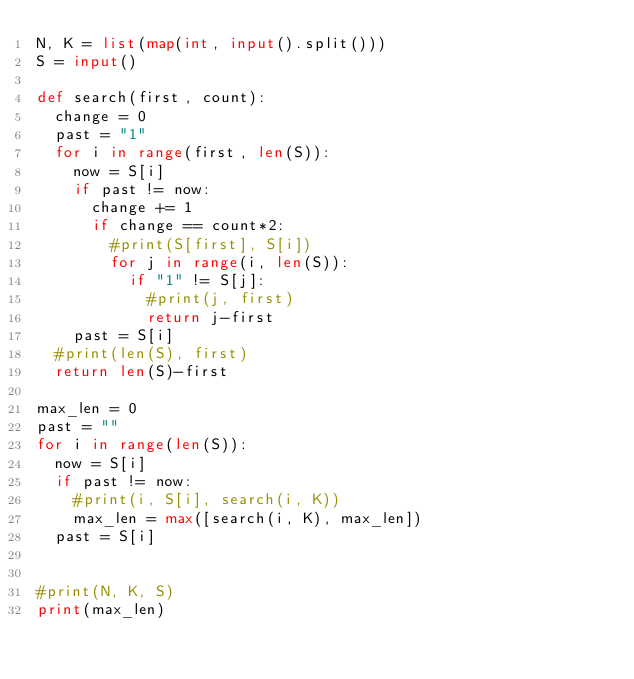<code> <loc_0><loc_0><loc_500><loc_500><_Python_>N, K = list(map(int, input().split()))
S = input()

def search(first, count):
  change = 0
  past = "1"
  for i in range(first, len(S)):
    now = S[i]
    if past != now:
      change += 1
      if change == count*2:
        #print(S[first], S[i])
        for j in range(i, len(S)):
          if "1" != S[j]:
            #print(j, first)
            return j-first
    past = S[i]
  #print(len(S), first)
  return len(S)-first

max_len = 0
past = ""
for i in range(len(S)):
  now = S[i]
  if past != now:
    #print(i, S[i], search(i, K))
    max_len = max([search(i, K), max_len])
  past = S[i] 
  

#print(N, K, S)
print(max_len)</code> 